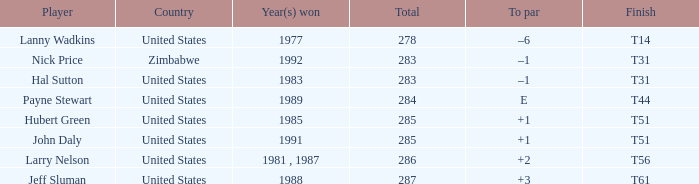What is Country, when Total is greater than 283, and when Year(s) Won is "1989"? United States. 